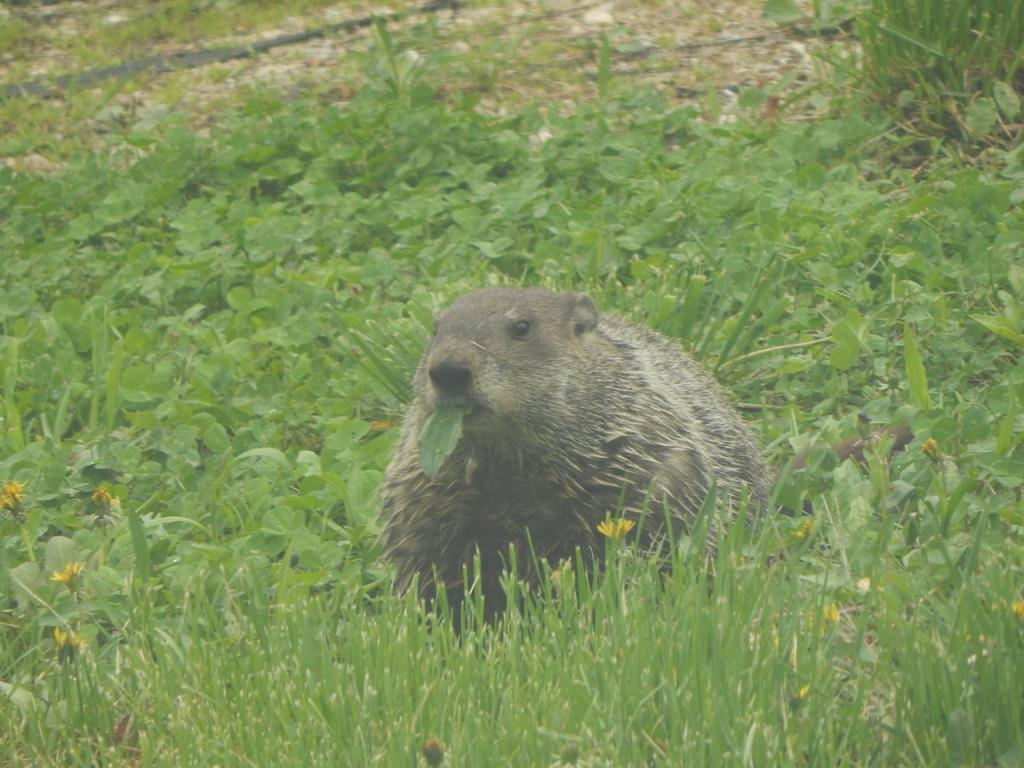What type of vegetation is present in the image? There is grass in the image. Can you describe the grass in more detail? There are grass plants in the image. What is the animal doing in the image? The animal is sitting in the grass. What is the animal eating in the image? The animal is eating a leaf in its mouth. What type of grain is being used to create the powder in the image? There is no grain or powder present in the image; it features grass and an animal eating a leaf. 